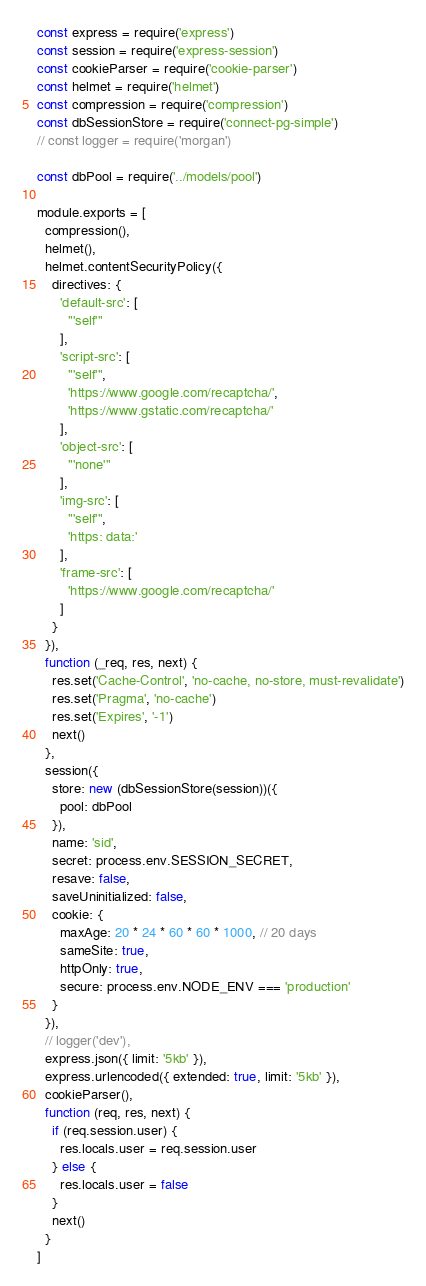<code> <loc_0><loc_0><loc_500><loc_500><_JavaScript_>const express = require('express')
const session = require('express-session')
const cookieParser = require('cookie-parser')
const helmet = require('helmet')
const compression = require('compression')
const dbSessionStore = require('connect-pg-simple')
// const logger = require('morgan')

const dbPool = require('../models/pool')

module.exports = [
  compression(),
  helmet(),
  helmet.contentSecurityPolicy({
    directives: {
      'default-src': [
        "'self'"
      ],
      'script-src': [
        "'self'",
        'https://www.google.com/recaptcha/',
        'https://www.gstatic.com/recaptcha/'
      ],
      'object-src': [
        "'none'"
      ],
      'img-src': [
        "'self'",
        'https: data:'
      ],
      'frame-src': [
        'https://www.google.com/recaptcha/'
      ]
    }
  }),
  function (_req, res, next) {
    res.set('Cache-Control', 'no-cache, no-store, must-revalidate')
    res.set('Pragma', 'no-cache')
    res.set('Expires', '-1')
    next()
  },
  session({
    store: new (dbSessionStore(session))({
      pool: dbPool
    }),
    name: 'sid',
    secret: process.env.SESSION_SECRET,
    resave: false,
    saveUninitialized: false,
    cookie: {
      maxAge: 20 * 24 * 60 * 60 * 1000, // 20 days
      sameSite: true,
      httpOnly: true,
      secure: process.env.NODE_ENV === 'production'
    }
  }),
  // logger('dev'),
  express.json({ limit: '5kb' }),
  express.urlencoded({ extended: true, limit: '5kb' }),
  cookieParser(),
  function (req, res, next) {
    if (req.session.user) {
      res.locals.user = req.session.user
    } else {
      res.locals.user = false
    }
    next()
  }
]
</code> 